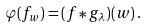<formula> <loc_0><loc_0><loc_500><loc_500>\varphi ( f _ { w } ) = ( f \ast g _ { \lambda } ) ( w ) \, .</formula> 